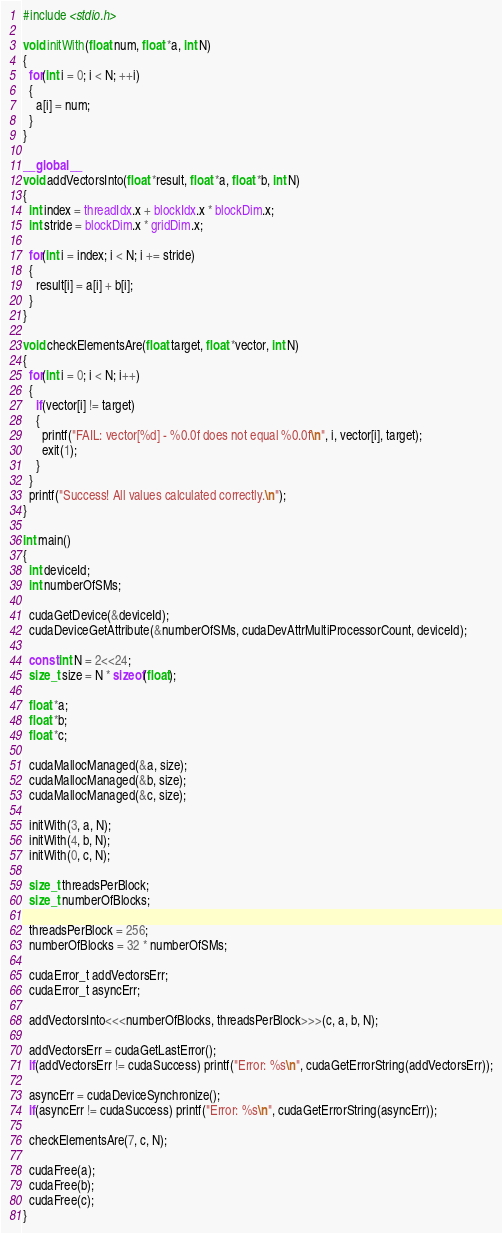<code> <loc_0><loc_0><loc_500><loc_500><_Cuda_>#include <stdio.h>

void initWith(float num, float *a, int N)
{
  for(int i = 0; i < N; ++i)
  {
    a[i] = num;
  }
}

__global__
void addVectorsInto(float *result, float *a, float *b, int N)
{
  int index = threadIdx.x + blockIdx.x * blockDim.x;
  int stride = blockDim.x * gridDim.x;

  for(int i = index; i < N; i += stride)
  {
    result[i] = a[i] + b[i];
  }
}

void checkElementsAre(float target, float *vector, int N)
{
  for(int i = 0; i < N; i++)
  {
    if(vector[i] != target)
    {
      printf("FAIL: vector[%d] - %0.0f does not equal %0.0f\n", i, vector[i], target);
      exit(1);
    }
  }
  printf("Success! All values calculated correctly.\n");
}

int main()
{
  int deviceId;
  int numberOfSMs;

  cudaGetDevice(&deviceId);
  cudaDeviceGetAttribute(&numberOfSMs, cudaDevAttrMultiProcessorCount, deviceId);

  const int N = 2<<24;
  size_t size = N * sizeof(float);

  float *a;
  float *b;
  float *c;

  cudaMallocManaged(&a, size);
  cudaMallocManaged(&b, size);
  cudaMallocManaged(&c, size);

  initWith(3, a, N);
  initWith(4, b, N);
  initWith(0, c, N);

  size_t threadsPerBlock;
  size_t numberOfBlocks;

  threadsPerBlock = 256;
  numberOfBlocks = 32 * numberOfSMs;

  cudaError_t addVectorsErr;
  cudaError_t asyncErr;

  addVectorsInto<<<numberOfBlocks, threadsPerBlock>>>(c, a, b, N);

  addVectorsErr = cudaGetLastError();
  if(addVectorsErr != cudaSuccess) printf("Error: %s\n", cudaGetErrorString(addVectorsErr));

  asyncErr = cudaDeviceSynchronize();
  if(asyncErr != cudaSuccess) printf("Error: %s\n", cudaGetErrorString(asyncErr));

  checkElementsAre(7, c, N);

  cudaFree(a);
  cudaFree(b);
  cudaFree(c);
}
</code> 